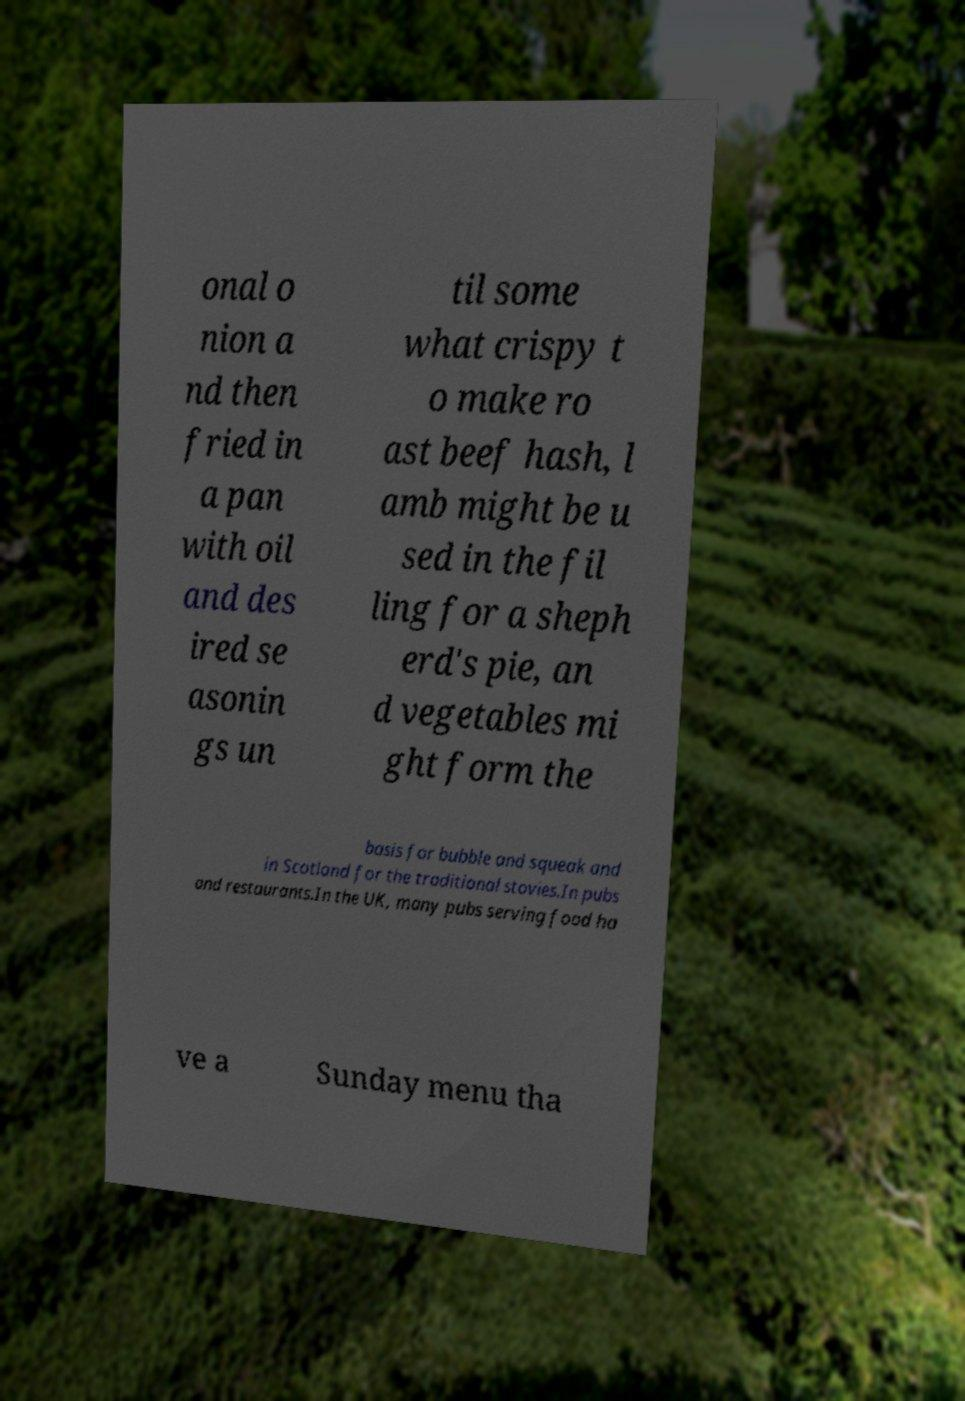Could you assist in decoding the text presented in this image and type it out clearly? onal o nion a nd then fried in a pan with oil and des ired se asonin gs un til some what crispy t o make ro ast beef hash, l amb might be u sed in the fil ling for a sheph erd's pie, an d vegetables mi ght form the basis for bubble and squeak and in Scotland for the traditional stovies.In pubs and restaurants.In the UK, many pubs serving food ha ve a Sunday menu tha 